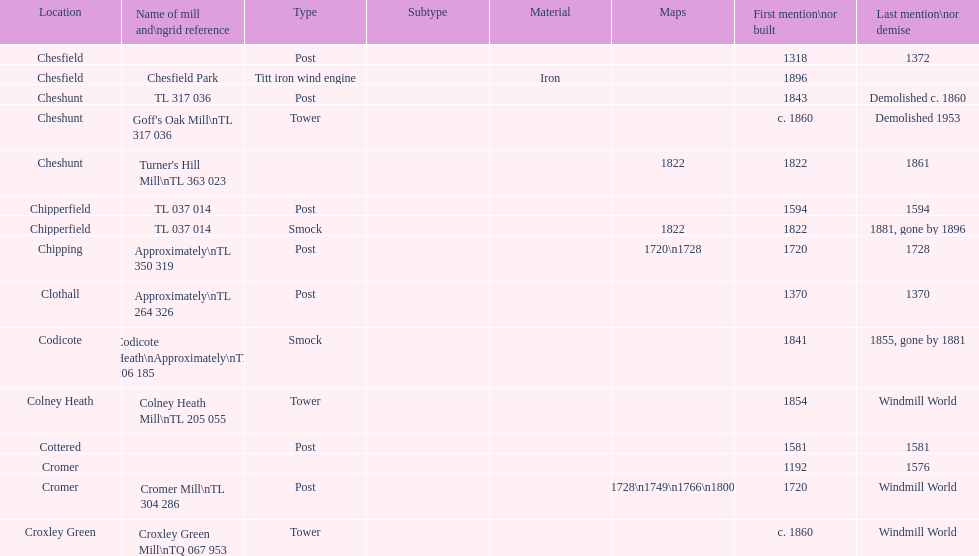Did cromer, chipperfield or cheshunt have the most windmills? Cheshunt. 